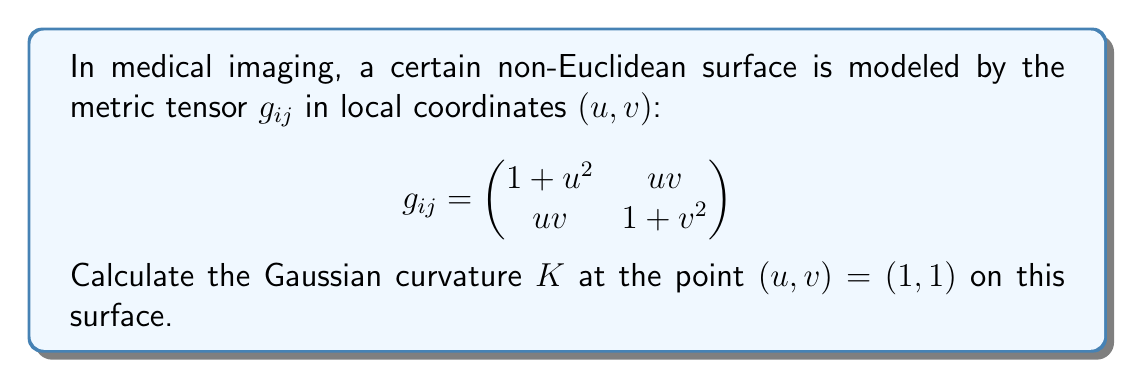Solve this math problem. To calculate the Gaussian curvature $K$ of a surface given its metric tensor $g_{ij}$, we need to follow these steps:

1. Calculate the inverse metric tensor $g^{ij}$.
2. Calculate the Christoffel symbols $\Gamma^k_{ij}$.
3. Calculate the Riemann curvature tensor $R^i_{jkl}$.
4. Calculate the Ricci tensor $R_{ij}$.
5. Calculate the scalar curvature $R$.
6. Calculate the Gaussian curvature $K = \frac{R}{2}$.

Let's go through each step:

1. The inverse metric tensor $g^{ij}$ is:

$$g^{ij} = \frac{1}{\det(g_{ij})} \begin{pmatrix}
1+v^2 & -uv \\
-uv & 1+u^2
\end{pmatrix}$$

where $\det(g_{ij}) = (1+u^2)(1+v^2) - u^2v^2 = 1 + u^2 + v^2$

2. The Christoffel symbols are given by:

$$\Gamma^k_{ij} = \frac{1}{2}g^{km}(\partial_i g_{jm} + \partial_j g_{im} - \partial_m g_{ij})$$

Calculating these for our metric, we get:

$$\Gamma^1_{11} = \frac{u}{1+u^2+v^2}, \quad \Gamma^1_{12} = \Gamma^1_{21} = \frac{v}{2(1+u^2+v^2)}, \quad \Gamma^1_{22} = -\frac{u}{1+u^2+v^2}$$
$$\Gamma^2_{11} = -\frac{v}{1+u^2+v^2}, \quad \Gamma^2_{12} = \Gamma^2_{21} = \frac{u}{2(1+u^2+v^2)}, \quad \Gamma^2_{22} = \frac{v}{1+u^2+v^2}$$

3. The Riemann curvature tensor is given by:

$$R^i_{jkl} = \partial_k \Gamma^i_{jl} - \partial_l \Gamma^i_{jk} + \Gamma^m_{jl}\Gamma^i_{mk} - \Gamma^m_{jk}\Gamma^i_{ml}$$

Calculating the non-zero components at $(u,v) = (1,1)$:

$$R^1_{212} = -R^1_{221} = R^2_{121} = -R^2_{112} = -\frac{1}{6}$$

4. The Ricci tensor is the contraction of the Riemann tensor:

$$R_{ij} = R^k_{ikj}$$

At $(1,1)$, we get:

$$R_{11} = R_{22} = -\frac{1}{6}, \quad R_{12} = R_{21} = 0$$

5. The scalar curvature is the trace of the Ricci tensor:

$$R = g^{ij}R_{ij} = g^{11}R_{11} + g^{22}R_{22} = -\frac{1}{3}$$

6. Finally, the Gaussian curvature is half the scalar curvature:

$$K = \frac{R}{2} = -\frac{1}{6}$$
Answer: The Gaussian curvature $K$ at the point $(u,v) = (1,1)$ on the given non-Euclidean surface is $-\frac{1}{6}$. 